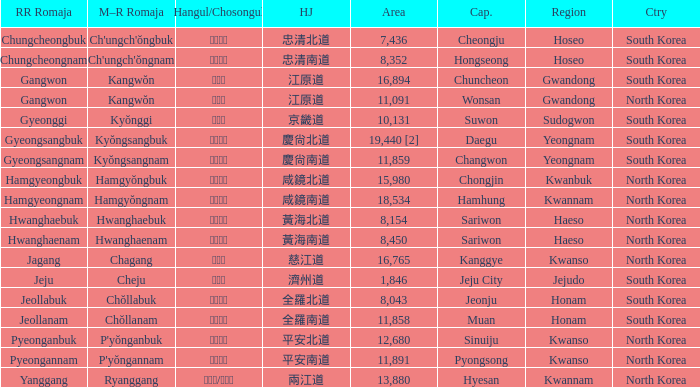What is the RR Romaja for the province that has Hangul of 강원도 and capital of Wonsan? Gangwon. 